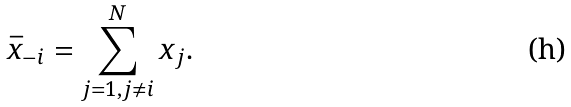Convert formula to latex. <formula><loc_0><loc_0><loc_500><loc_500>\bar { x } _ { - i } = \sum _ { j = 1 , j \neq i } ^ { N } x _ { j } .</formula> 